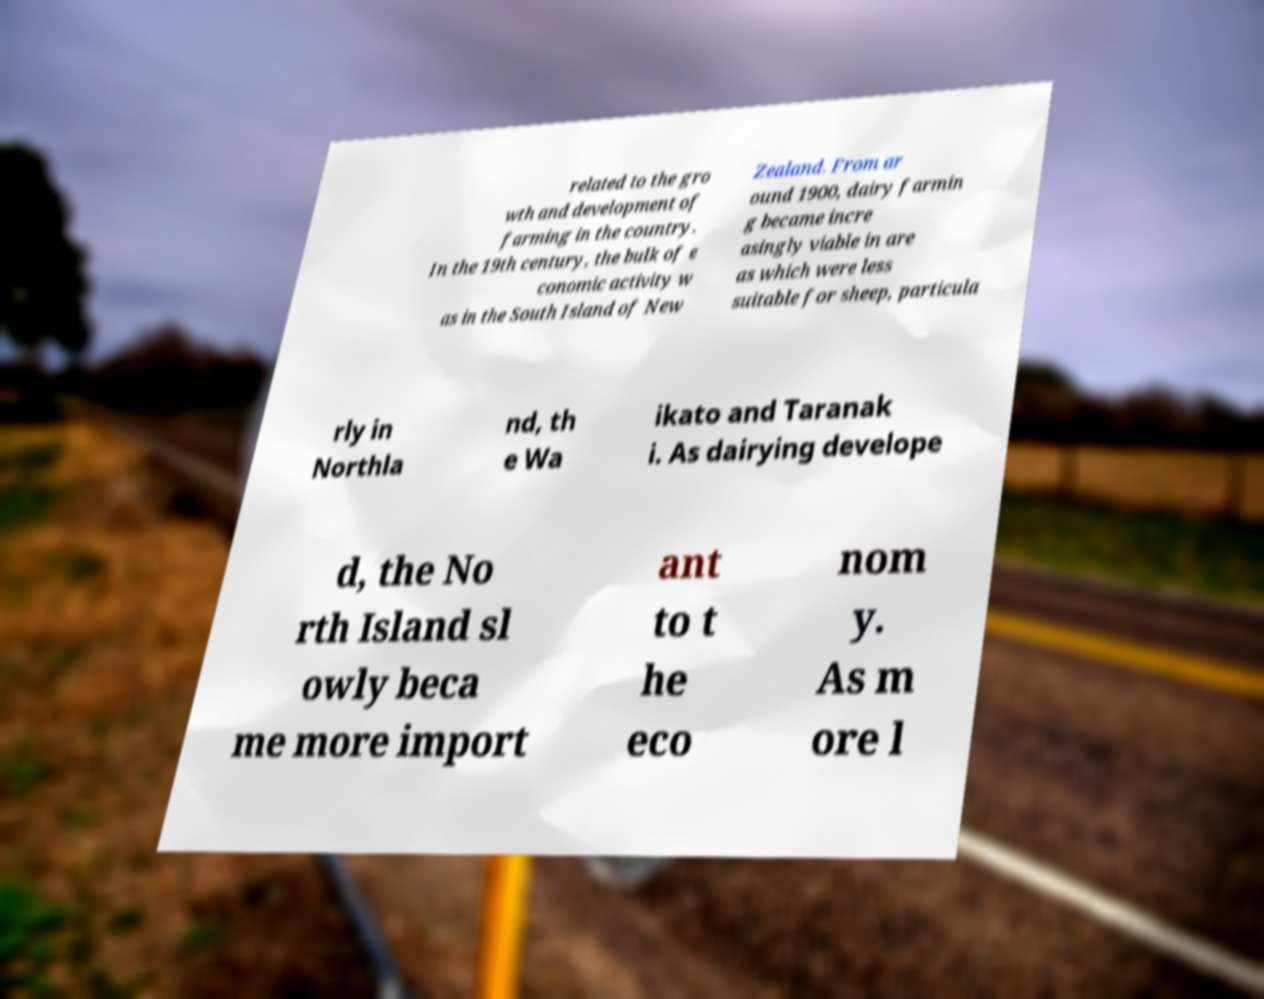Please read and relay the text visible in this image. What does it say? related to the gro wth and development of farming in the country. In the 19th century, the bulk of e conomic activity w as in the South Island of New Zealand. From ar ound 1900, dairy farmin g became incre asingly viable in are as which were less suitable for sheep, particula rly in Northla nd, th e Wa ikato and Taranak i. As dairying develope d, the No rth Island sl owly beca me more import ant to t he eco nom y. As m ore l 